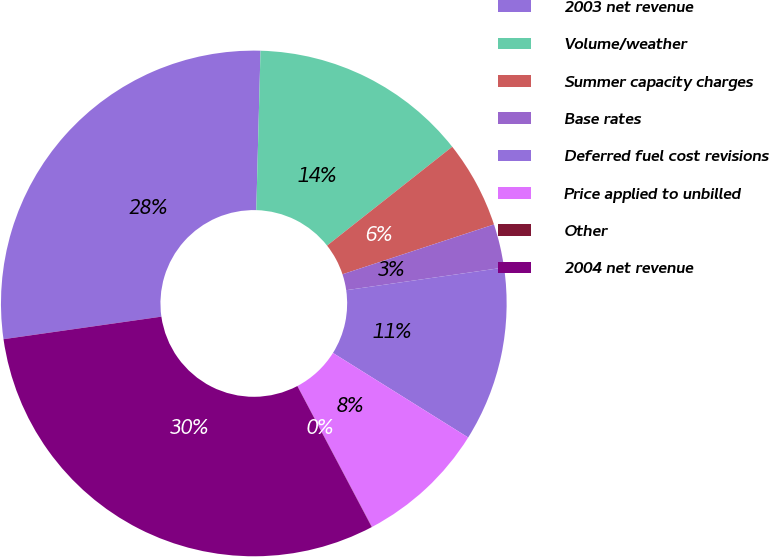<chart> <loc_0><loc_0><loc_500><loc_500><pie_chart><fcel>2003 net revenue<fcel>Volume/weather<fcel>Summer capacity charges<fcel>Base rates<fcel>Deferred fuel cost revisions<fcel>Price applied to unbilled<fcel>Other<fcel>2004 net revenue<nl><fcel>27.68%<fcel>13.94%<fcel>5.58%<fcel>2.79%<fcel>11.16%<fcel>8.37%<fcel>0.01%<fcel>30.47%<nl></chart> 